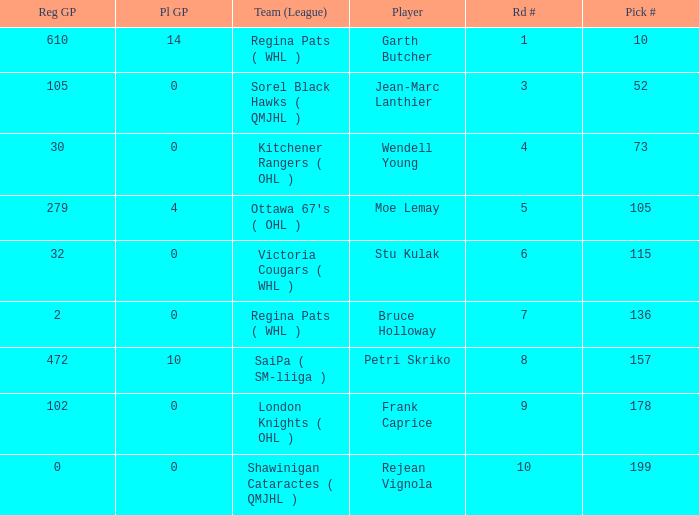What is the total number of Pl GP when the pick number is 199 and the Reg GP is bigger than 0? None. 